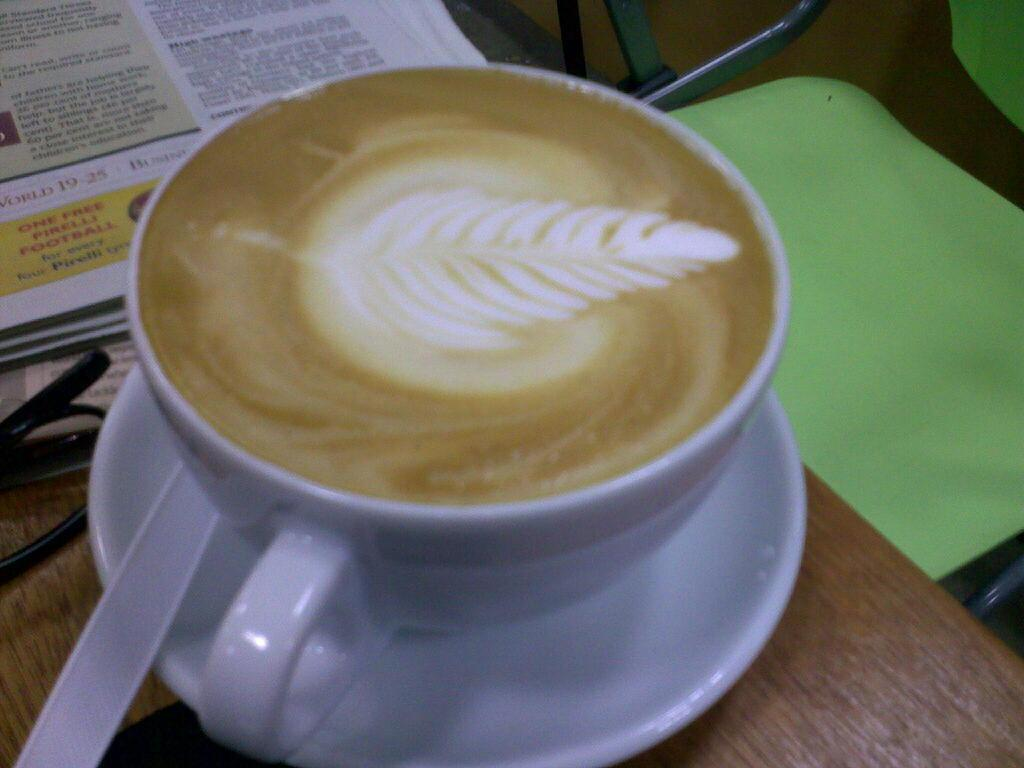What is in the image that is typically used for drinking hot beverages? There is a coffee cup in the image. What accompanies the coffee cup in the image? The coffee cup is served with a sauceramic saucer. Where is the coffee cup placed in the image? The coffee cup is placed on a table. What other items are near the coffee cup on the table? There are spectacles and a newspaper beside the coffee cup. What is the seating arrangement in relation to the table? There is a chair in front of the table. What type of wave can be seen crashing on the shore in the image? There is no wave or shore present in the image; it features a coffee cup, saucer, spectacles, newspaper, and a chair. 